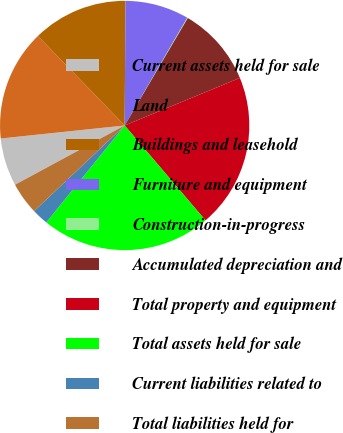Convert chart to OTSL. <chart><loc_0><loc_0><loc_500><loc_500><pie_chart><fcel>Current assets held for sale<fcel>Land<fcel>Buildings and leasehold<fcel>Furniture and equipment<fcel>Construction-in-progress<fcel>Accumulated depreciation and<fcel>Total property and equipment<fcel>Total assets held for sale<fcel>Current liabilities related to<fcel>Total liabilities held for<nl><fcel>6.22%<fcel>14.41%<fcel>12.36%<fcel>8.27%<fcel>0.08%<fcel>10.31%<fcel>20.0%<fcel>22.05%<fcel>2.12%<fcel>4.17%<nl></chart> 